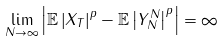Convert formula to latex. <formula><loc_0><loc_0><loc_500><loc_500>\lim _ { N \rightarrow \infty } \left | \mathbb { E } \left | X _ { T } \right | ^ { p } - \mathbb { E } \left | Y ^ { N } _ { N } \right | ^ { p } \right | = \infty</formula> 